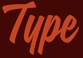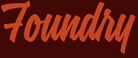What words are shown in these images in order, separated by a semicolon? Type; Foundry 